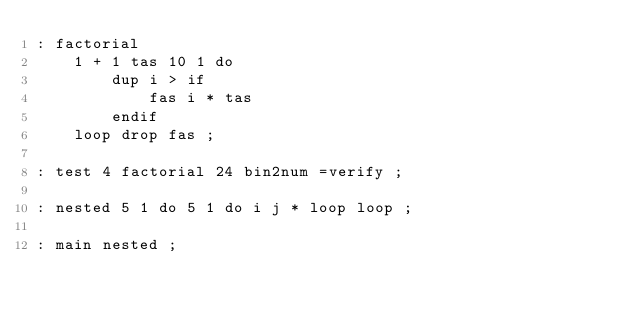<code> <loc_0><loc_0><loc_500><loc_500><_Forth_>: factorial
    1 + 1 tas 10 1 do
        dup i > if
            fas i * tas
        endif
    loop drop fas ;

: test 4 factorial 24 bin2num =verify ;

: nested 5 1 do 5 1 do i j * loop loop ;

: main nested ;

</code> 